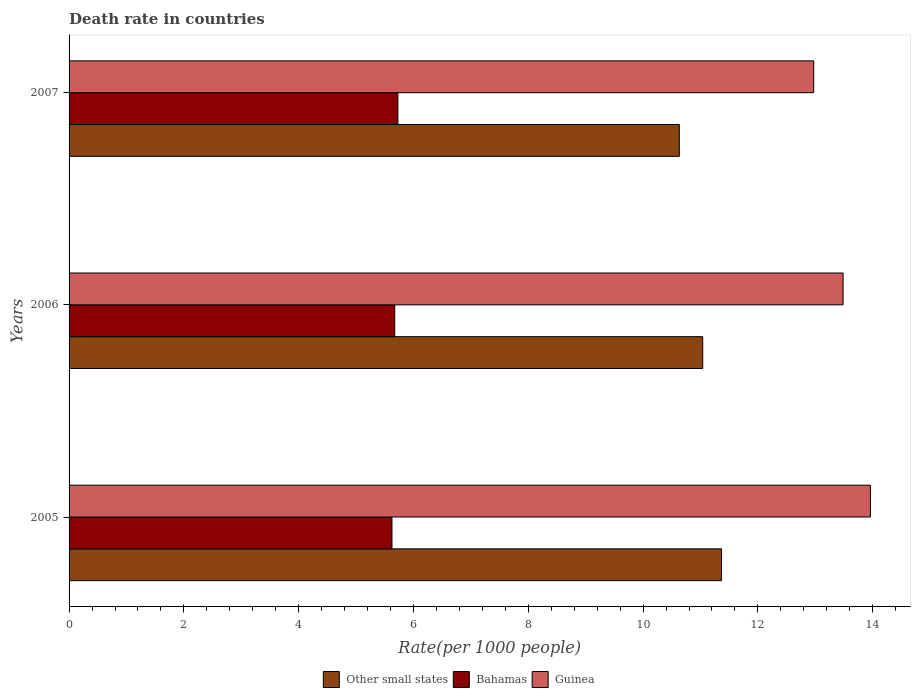Are the number of bars per tick equal to the number of legend labels?
Your answer should be compact. Yes. Are the number of bars on each tick of the Y-axis equal?
Your response must be concise. Yes. What is the death rate in Guinea in 2007?
Provide a short and direct response. 12.97. Across all years, what is the maximum death rate in Guinea?
Provide a succinct answer. 13.96. Across all years, what is the minimum death rate in Guinea?
Keep it short and to the point. 12.97. In which year was the death rate in Other small states maximum?
Ensure brevity in your answer.  2005. What is the total death rate in Guinea in the graph?
Your answer should be very brief. 40.42. What is the difference between the death rate in Guinea in 2005 and that in 2006?
Provide a short and direct response. 0.48. What is the difference between the death rate in Guinea in 2006 and the death rate in Bahamas in 2005?
Your answer should be compact. 7.86. What is the average death rate in Other small states per year?
Give a very brief answer. 11.01. In the year 2005, what is the difference between the death rate in Guinea and death rate in Bahamas?
Offer a terse response. 8.34. In how many years, is the death rate in Guinea greater than 6.4 ?
Your answer should be very brief. 3. What is the ratio of the death rate in Other small states in 2005 to that in 2006?
Make the answer very short. 1.03. Is the difference between the death rate in Guinea in 2005 and 2007 greater than the difference between the death rate in Bahamas in 2005 and 2007?
Provide a succinct answer. Yes. What is the difference between the highest and the second highest death rate in Bahamas?
Provide a succinct answer. 0.06. What is the difference between the highest and the lowest death rate in Bahamas?
Provide a short and direct response. 0.1. Is the sum of the death rate in Other small states in 2006 and 2007 greater than the maximum death rate in Guinea across all years?
Provide a succinct answer. Yes. What does the 2nd bar from the top in 2007 represents?
Keep it short and to the point. Bahamas. What does the 2nd bar from the bottom in 2005 represents?
Offer a terse response. Bahamas. Is it the case that in every year, the sum of the death rate in Other small states and death rate in Guinea is greater than the death rate in Bahamas?
Your answer should be compact. Yes. Are all the bars in the graph horizontal?
Make the answer very short. Yes. How many years are there in the graph?
Provide a short and direct response. 3. Does the graph contain grids?
Make the answer very short. No. Where does the legend appear in the graph?
Your response must be concise. Bottom center. What is the title of the graph?
Your answer should be very brief. Death rate in countries. Does "Equatorial Guinea" appear as one of the legend labels in the graph?
Provide a short and direct response. No. What is the label or title of the X-axis?
Provide a short and direct response. Rate(per 1000 people). What is the label or title of the Y-axis?
Ensure brevity in your answer.  Years. What is the Rate(per 1000 people) in Other small states in 2005?
Provide a succinct answer. 11.37. What is the Rate(per 1000 people) in Bahamas in 2005?
Keep it short and to the point. 5.62. What is the Rate(per 1000 people) in Guinea in 2005?
Offer a terse response. 13.96. What is the Rate(per 1000 people) in Other small states in 2006?
Provide a short and direct response. 11.04. What is the Rate(per 1000 people) in Bahamas in 2006?
Ensure brevity in your answer.  5.67. What is the Rate(per 1000 people) of Guinea in 2006?
Your answer should be compact. 13.48. What is the Rate(per 1000 people) in Other small states in 2007?
Provide a short and direct response. 10.63. What is the Rate(per 1000 people) of Bahamas in 2007?
Ensure brevity in your answer.  5.73. What is the Rate(per 1000 people) in Guinea in 2007?
Provide a short and direct response. 12.97. Across all years, what is the maximum Rate(per 1000 people) of Other small states?
Make the answer very short. 11.37. Across all years, what is the maximum Rate(per 1000 people) in Bahamas?
Ensure brevity in your answer.  5.73. Across all years, what is the maximum Rate(per 1000 people) in Guinea?
Offer a terse response. 13.96. Across all years, what is the minimum Rate(per 1000 people) of Other small states?
Keep it short and to the point. 10.63. Across all years, what is the minimum Rate(per 1000 people) of Bahamas?
Give a very brief answer. 5.62. Across all years, what is the minimum Rate(per 1000 people) in Guinea?
Make the answer very short. 12.97. What is the total Rate(per 1000 people) of Other small states in the graph?
Ensure brevity in your answer.  33.04. What is the total Rate(per 1000 people) of Bahamas in the graph?
Make the answer very short. 17.03. What is the total Rate(per 1000 people) of Guinea in the graph?
Your answer should be very brief. 40.42. What is the difference between the Rate(per 1000 people) of Other small states in 2005 and that in 2006?
Ensure brevity in your answer.  0.33. What is the difference between the Rate(per 1000 people) in Bahamas in 2005 and that in 2006?
Offer a terse response. -0.05. What is the difference between the Rate(per 1000 people) in Guinea in 2005 and that in 2006?
Make the answer very short. 0.48. What is the difference between the Rate(per 1000 people) in Other small states in 2005 and that in 2007?
Provide a short and direct response. 0.74. What is the difference between the Rate(per 1000 people) in Bahamas in 2005 and that in 2007?
Offer a terse response. -0.1. What is the difference between the Rate(per 1000 people) of Other small states in 2006 and that in 2007?
Your response must be concise. 0.41. What is the difference between the Rate(per 1000 people) of Bahamas in 2006 and that in 2007?
Ensure brevity in your answer.  -0.06. What is the difference between the Rate(per 1000 people) of Guinea in 2006 and that in 2007?
Give a very brief answer. 0.51. What is the difference between the Rate(per 1000 people) in Other small states in 2005 and the Rate(per 1000 people) in Bahamas in 2006?
Offer a terse response. 5.69. What is the difference between the Rate(per 1000 people) in Other small states in 2005 and the Rate(per 1000 people) in Guinea in 2006?
Provide a short and direct response. -2.12. What is the difference between the Rate(per 1000 people) of Bahamas in 2005 and the Rate(per 1000 people) of Guinea in 2006?
Ensure brevity in your answer.  -7.86. What is the difference between the Rate(per 1000 people) of Other small states in 2005 and the Rate(per 1000 people) of Bahamas in 2007?
Ensure brevity in your answer.  5.64. What is the difference between the Rate(per 1000 people) in Other small states in 2005 and the Rate(per 1000 people) in Guinea in 2007?
Offer a terse response. -1.61. What is the difference between the Rate(per 1000 people) in Bahamas in 2005 and the Rate(per 1000 people) in Guinea in 2007?
Provide a short and direct response. -7.35. What is the difference between the Rate(per 1000 people) in Other small states in 2006 and the Rate(per 1000 people) in Bahamas in 2007?
Provide a succinct answer. 5.31. What is the difference between the Rate(per 1000 people) of Other small states in 2006 and the Rate(per 1000 people) of Guinea in 2007?
Your response must be concise. -1.93. What is the difference between the Rate(per 1000 people) of Bahamas in 2006 and the Rate(per 1000 people) of Guinea in 2007?
Provide a succinct answer. -7.3. What is the average Rate(per 1000 people) of Other small states per year?
Your answer should be very brief. 11.01. What is the average Rate(per 1000 people) in Bahamas per year?
Your answer should be very brief. 5.68. What is the average Rate(per 1000 people) of Guinea per year?
Offer a terse response. 13.47. In the year 2005, what is the difference between the Rate(per 1000 people) of Other small states and Rate(per 1000 people) of Bahamas?
Provide a short and direct response. 5.74. In the year 2005, what is the difference between the Rate(per 1000 people) of Other small states and Rate(per 1000 people) of Guinea?
Keep it short and to the point. -2.59. In the year 2005, what is the difference between the Rate(per 1000 people) in Bahamas and Rate(per 1000 people) in Guinea?
Offer a very short reply. -8.34. In the year 2006, what is the difference between the Rate(per 1000 people) of Other small states and Rate(per 1000 people) of Bahamas?
Offer a very short reply. 5.37. In the year 2006, what is the difference between the Rate(per 1000 people) in Other small states and Rate(per 1000 people) in Guinea?
Your response must be concise. -2.45. In the year 2006, what is the difference between the Rate(per 1000 people) of Bahamas and Rate(per 1000 people) of Guinea?
Make the answer very short. -7.81. In the year 2007, what is the difference between the Rate(per 1000 people) in Other small states and Rate(per 1000 people) in Bahamas?
Give a very brief answer. 4.9. In the year 2007, what is the difference between the Rate(per 1000 people) of Other small states and Rate(per 1000 people) of Guinea?
Your answer should be very brief. -2.34. In the year 2007, what is the difference between the Rate(per 1000 people) in Bahamas and Rate(per 1000 people) in Guinea?
Keep it short and to the point. -7.24. What is the ratio of the Rate(per 1000 people) of Other small states in 2005 to that in 2006?
Ensure brevity in your answer.  1.03. What is the ratio of the Rate(per 1000 people) in Bahamas in 2005 to that in 2006?
Your answer should be very brief. 0.99. What is the ratio of the Rate(per 1000 people) in Guinea in 2005 to that in 2006?
Make the answer very short. 1.04. What is the ratio of the Rate(per 1000 people) of Other small states in 2005 to that in 2007?
Your answer should be compact. 1.07. What is the ratio of the Rate(per 1000 people) of Guinea in 2005 to that in 2007?
Give a very brief answer. 1.08. What is the ratio of the Rate(per 1000 people) in Other small states in 2006 to that in 2007?
Provide a succinct answer. 1.04. What is the ratio of the Rate(per 1000 people) in Guinea in 2006 to that in 2007?
Keep it short and to the point. 1.04. What is the difference between the highest and the second highest Rate(per 1000 people) of Other small states?
Your answer should be compact. 0.33. What is the difference between the highest and the second highest Rate(per 1000 people) in Bahamas?
Keep it short and to the point. 0.06. What is the difference between the highest and the second highest Rate(per 1000 people) of Guinea?
Provide a succinct answer. 0.48. What is the difference between the highest and the lowest Rate(per 1000 people) of Other small states?
Offer a very short reply. 0.74. What is the difference between the highest and the lowest Rate(per 1000 people) in Bahamas?
Give a very brief answer. 0.1. 